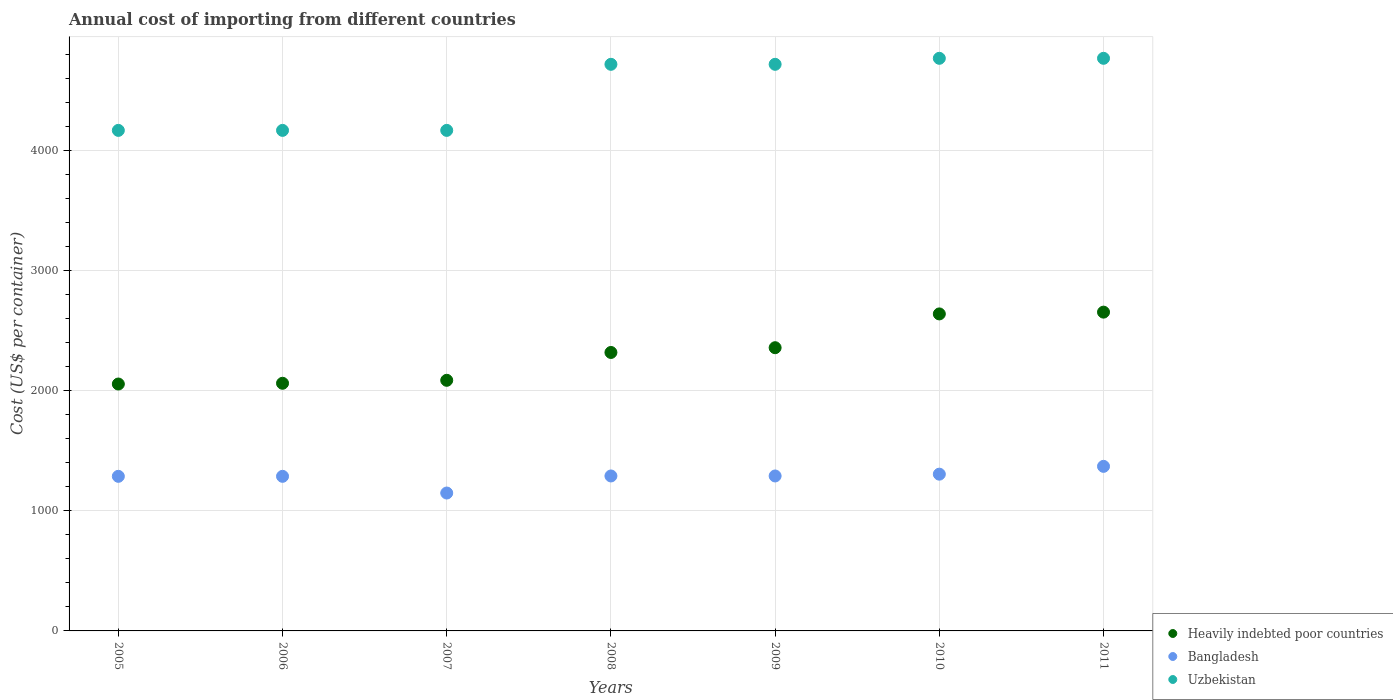How many different coloured dotlines are there?
Make the answer very short. 3. Is the number of dotlines equal to the number of legend labels?
Provide a succinct answer. Yes. What is the total annual cost of importing in Heavily indebted poor countries in 2008?
Your answer should be very brief. 2318.13. Across all years, what is the maximum total annual cost of importing in Bangladesh?
Provide a succinct answer. 1370. Across all years, what is the minimum total annual cost of importing in Heavily indebted poor countries?
Your answer should be compact. 2055.43. What is the total total annual cost of importing in Heavily indebted poor countries in the graph?
Offer a very short reply. 1.62e+04. What is the difference between the total annual cost of importing in Heavily indebted poor countries in 2009 and that in 2010?
Offer a terse response. -281.26. What is the difference between the total annual cost of importing in Heavily indebted poor countries in 2010 and the total annual cost of importing in Uzbekistan in 2009?
Provide a succinct answer. -2077.95. What is the average total annual cost of importing in Heavily indebted poor countries per year?
Make the answer very short. 2310.33. In the year 2005, what is the difference between the total annual cost of importing in Uzbekistan and total annual cost of importing in Bangladesh?
Offer a terse response. 2880. In how many years, is the total annual cost of importing in Heavily indebted poor countries greater than 3800 US$?
Your answer should be very brief. 0. What is the ratio of the total annual cost of importing in Heavily indebted poor countries in 2005 to that in 2008?
Give a very brief answer. 0.89. Is the total annual cost of importing in Heavily indebted poor countries in 2006 less than that in 2007?
Your answer should be compact. Yes. Is the difference between the total annual cost of importing in Uzbekistan in 2005 and 2008 greater than the difference between the total annual cost of importing in Bangladesh in 2005 and 2008?
Your response must be concise. No. What is the difference between the highest and the second highest total annual cost of importing in Bangladesh?
Your response must be concise. 65. What is the difference between the highest and the lowest total annual cost of importing in Bangladesh?
Make the answer very short. 222. In how many years, is the total annual cost of importing in Heavily indebted poor countries greater than the average total annual cost of importing in Heavily indebted poor countries taken over all years?
Provide a succinct answer. 4. Is it the case that in every year, the sum of the total annual cost of importing in Bangladesh and total annual cost of importing in Uzbekistan  is greater than the total annual cost of importing in Heavily indebted poor countries?
Ensure brevity in your answer.  Yes. Does the total annual cost of importing in Uzbekistan monotonically increase over the years?
Give a very brief answer. No. Is the total annual cost of importing in Heavily indebted poor countries strictly greater than the total annual cost of importing in Uzbekistan over the years?
Offer a very short reply. No. Is the total annual cost of importing in Bangladesh strictly less than the total annual cost of importing in Uzbekistan over the years?
Provide a succinct answer. Yes. What is the difference between two consecutive major ticks on the Y-axis?
Your answer should be very brief. 1000. Does the graph contain grids?
Give a very brief answer. Yes. What is the title of the graph?
Ensure brevity in your answer.  Annual cost of importing from different countries. What is the label or title of the X-axis?
Ensure brevity in your answer.  Years. What is the label or title of the Y-axis?
Provide a succinct answer. Cost (US$ per container). What is the Cost (US$ per container) of Heavily indebted poor countries in 2005?
Keep it short and to the point. 2055.43. What is the Cost (US$ per container) in Bangladesh in 2005?
Keep it short and to the point. 1287. What is the Cost (US$ per container) of Uzbekistan in 2005?
Your answer should be compact. 4167. What is the Cost (US$ per container) of Heavily indebted poor countries in 2006?
Provide a succinct answer. 2061.68. What is the Cost (US$ per container) of Bangladesh in 2006?
Offer a very short reply. 1287. What is the Cost (US$ per container) of Uzbekistan in 2006?
Keep it short and to the point. 4167. What is the Cost (US$ per container) of Heavily indebted poor countries in 2007?
Keep it short and to the point. 2086.37. What is the Cost (US$ per container) in Bangladesh in 2007?
Ensure brevity in your answer.  1148. What is the Cost (US$ per container) of Uzbekistan in 2007?
Offer a terse response. 4167. What is the Cost (US$ per container) of Heavily indebted poor countries in 2008?
Keep it short and to the point. 2318.13. What is the Cost (US$ per container) of Bangladesh in 2008?
Your response must be concise. 1290. What is the Cost (US$ per container) of Uzbekistan in 2008?
Offer a terse response. 4717. What is the Cost (US$ per container) of Heavily indebted poor countries in 2009?
Provide a succinct answer. 2357.79. What is the Cost (US$ per container) of Bangladesh in 2009?
Give a very brief answer. 1290. What is the Cost (US$ per container) in Uzbekistan in 2009?
Offer a terse response. 4717. What is the Cost (US$ per container) of Heavily indebted poor countries in 2010?
Provide a succinct answer. 2639.05. What is the Cost (US$ per container) of Bangladesh in 2010?
Give a very brief answer. 1305. What is the Cost (US$ per container) in Uzbekistan in 2010?
Provide a short and direct response. 4767. What is the Cost (US$ per container) in Heavily indebted poor countries in 2011?
Keep it short and to the point. 2653.87. What is the Cost (US$ per container) in Bangladesh in 2011?
Your answer should be compact. 1370. What is the Cost (US$ per container) of Uzbekistan in 2011?
Provide a succinct answer. 4767. Across all years, what is the maximum Cost (US$ per container) of Heavily indebted poor countries?
Offer a terse response. 2653.87. Across all years, what is the maximum Cost (US$ per container) of Bangladesh?
Your answer should be very brief. 1370. Across all years, what is the maximum Cost (US$ per container) of Uzbekistan?
Provide a succinct answer. 4767. Across all years, what is the minimum Cost (US$ per container) in Heavily indebted poor countries?
Your answer should be compact. 2055.43. Across all years, what is the minimum Cost (US$ per container) in Bangladesh?
Keep it short and to the point. 1148. Across all years, what is the minimum Cost (US$ per container) in Uzbekistan?
Ensure brevity in your answer.  4167. What is the total Cost (US$ per container) in Heavily indebted poor countries in the graph?
Keep it short and to the point. 1.62e+04. What is the total Cost (US$ per container) of Bangladesh in the graph?
Offer a very short reply. 8977. What is the total Cost (US$ per container) in Uzbekistan in the graph?
Your answer should be very brief. 3.15e+04. What is the difference between the Cost (US$ per container) in Heavily indebted poor countries in 2005 and that in 2006?
Your answer should be compact. -6.25. What is the difference between the Cost (US$ per container) of Bangladesh in 2005 and that in 2006?
Offer a very short reply. 0. What is the difference between the Cost (US$ per container) in Heavily indebted poor countries in 2005 and that in 2007?
Give a very brief answer. -30.94. What is the difference between the Cost (US$ per container) of Bangladesh in 2005 and that in 2007?
Your response must be concise. 139. What is the difference between the Cost (US$ per container) of Heavily indebted poor countries in 2005 and that in 2008?
Your response must be concise. -262.7. What is the difference between the Cost (US$ per container) in Uzbekistan in 2005 and that in 2008?
Give a very brief answer. -550. What is the difference between the Cost (US$ per container) in Heavily indebted poor countries in 2005 and that in 2009?
Offer a very short reply. -302.36. What is the difference between the Cost (US$ per container) in Bangladesh in 2005 and that in 2009?
Your answer should be compact. -3. What is the difference between the Cost (US$ per container) in Uzbekistan in 2005 and that in 2009?
Offer a very short reply. -550. What is the difference between the Cost (US$ per container) of Heavily indebted poor countries in 2005 and that in 2010?
Your answer should be very brief. -583.62. What is the difference between the Cost (US$ per container) of Bangladesh in 2005 and that in 2010?
Make the answer very short. -18. What is the difference between the Cost (US$ per container) of Uzbekistan in 2005 and that in 2010?
Give a very brief answer. -600. What is the difference between the Cost (US$ per container) of Heavily indebted poor countries in 2005 and that in 2011?
Your response must be concise. -598.44. What is the difference between the Cost (US$ per container) of Bangladesh in 2005 and that in 2011?
Offer a very short reply. -83. What is the difference between the Cost (US$ per container) in Uzbekistan in 2005 and that in 2011?
Offer a very short reply. -600. What is the difference between the Cost (US$ per container) in Heavily indebted poor countries in 2006 and that in 2007?
Give a very brief answer. -24.68. What is the difference between the Cost (US$ per container) of Bangladesh in 2006 and that in 2007?
Give a very brief answer. 139. What is the difference between the Cost (US$ per container) in Heavily indebted poor countries in 2006 and that in 2008?
Your answer should be compact. -256.45. What is the difference between the Cost (US$ per container) in Bangladesh in 2006 and that in 2008?
Offer a very short reply. -3. What is the difference between the Cost (US$ per container) in Uzbekistan in 2006 and that in 2008?
Offer a terse response. -550. What is the difference between the Cost (US$ per container) of Heavily indebted poor countries in 2006 and that in 2009?
Offer a very short reply. -296.11. What is the difference between the Cost (US$ per container) in Uzbekistan in 2006 and that in 2009?
Make the answer very short. -550. What is the difference between the Cost (US$ per container) of Heavily indebted poor countries in 2006 and that in 2010?
Offer a terse response. -577.37. What is the difference between the Cost (US$ per container) of Bangladesh in 2006 and that in 2010?
Give a very brief answer. -18. What is the difference between the Cost (US$ per container) of Uzbekistan in 2006 and that in 2010?
Your response must be concise. -600. What is the difference between the Cost (US$ per container) in Heavily indebted poor countries in 2006 and that in 2011?
Keep it short and to the point. -592.18. What is the difference between the Cost (US$ per container) in Bangladesh in 2006 and that in 2011?
Your answer should be very brief. -83. What is the difference between the Cost (US$ per container) in Uzbekistan in 2006 and that in 2011?
Provide a succinct answer. -600. What is the difference between the Cost (US$ per container) in Heavily indebted poor countries in 2007 and that in 2008?
Ensure brevity in your answer.  -231.76. What is the difference between the Cost (US$ per container) in Bangladesh in 2007 and that in 2008?
Make the answer very short. -142. What is the difference between the Cost (US$ per container) in Uzbekistan in 2007 and that in 2008?
Ensure brevity in your answer.  -550. What is the difference between the Cost (US$ per container) of Heavily indebted poor countries in 2007 and that in 2009?
Your answer should be compact. -271.42. What is the difference between the Cost (US$ per container) in Bangladesh in 2007 and that in 2009?
Offer a terse response. -142. What is the difference between the Cost (US$ per container) of Uzbekistan in 2007 and that in 2009?
Your response must be concise. -550. What is the difference between the Cost (US$ per container) of Heavily indebted poor countries in 2007 and that in 2010?
Your answer should be compact. -552.68. What is the difference between the Cost (US$ per container) in Bangladesh in 2007 and that in 2010?
Give a very brief answer. -157. What is the difference between the Cost (US$ per container) of Uzbekistan in 2007 and that in 2010?
Your answer should be compact. -600. What is the difference between the Cost (US$ per container) in Heavily indebted poor countries in 2007 and that in 2011?
Provide a short and direct response. -567.5. What is the difference between the Cost (US$ per container) of Bangladesh in 2007 and that in 2011?
Ensure brevity in your answer.  -222. What is the difference between the Cost (US$ per container) in Uzbekistan in 2007 and that in 2011?
Your answer should be very brief. -600. What is the difference between the Cost (US$ per container) of Heavily indebted poor countries in 2008 and that in 2009?
Give a very brief answer. -39.66. What is the difference between the Cost (US$ per container) of Heavily indebted poor countries in 2008 and that in 2010?
Provide a succinct answer. -320.92. What is the difference between the Cost (US$ per container) in Uzbekistan in 2008 and that in 2010?
Make the answer very short. -50. What is the difference between the Cost (US$ per container) in Heavily indebted poor countries in 2008 and that in 2011?
Keep it short and to the point. -335.74. What is the difference between the Cost (US$ per container) of Bangladesh in 2008 and that in 2011?
Your response must be concise. -80. What is the difference between the Cost (US$ per container) in Heavily indebted poor countries in 2009 and that in 2010?
Provide a short and direct response. -281.26. What is the difference between the Cost (US$ per container) of Bangladesh in 2009 and that in 2010?
Ensure brevity in your answer.  -15. What is the difference between the Cost (US$ per container) of Heavily indebted poor countries in 2009 and that in 2011?
Your answer should be very brief. -296.08. What is the difference between the Cost (US$ per container) in Bangladesh in 2009 and that in 2011?
Provide a succinct answer. -80. What is the difference between the Cost (US$ per container) in Heavily indebted poor countries in 2010 and that in 2011?
Provide a short and direct response. -14.82. What is the difference between the Cost (US$ per container) of Bangladesh in 2010 and that in 2011?
Offer a terse response. -65. What is the difference between the Cost (US$ per container) of Uzbekistan in 2010 and that in 2011?
Provide a succinct answer. 0. What is the difference between the Cost (US$ per container) of Heavily indebted poor countries in 2005 and the Cost (US$ per container) of Bangladesh in 2006?
Ensure brevity in your answer.  768.43. What is the difference between the Cost (US$ per container) of Heavily indebted poor countries in 2005 and the Cost (US$ per container) of Uzbekistan in 2006?
Your answer should be compact. -2111.57. What is the difference between the Cost (US$ per container) of Bangladesh in 2005 and the Cost (US$ per container) of Uzbekistan in 2006?
Give a very brief answer. -2880. What is the difference between the Cost (US$ per container) in Heavily indebted poor countries in 2005 and the Cost (US$ per container) in Bangladesh in 2007?
Ensure brevity in your answer.  907.43. What is the difference between the Cost (US$ per container) in Heavily indebted poor countries in 2005 and the Cost (US$ per container) in Uzbekistan in 2007?
Your response must be concise. -2111.57. What is the difference between the Cost (US$ per container) of Bangladesh in 2005 and the Cost (US$ per container) of Uzbekistan in 2007?
Keep it short and to the point. -2880. What is the difference between the Cost (US$ per container) of Heavily indebted poor countries in 2005 and the Cost (US$ per container) of Bangladesh in 2008?
Ensure brevity in your answer.  765.43. What is the difference between the Cost (US$ per container) in Heavily indebted poor countries in 2005 and the Cost (US$ per container) in Uzbekistan in 2008?
Give a very brief answer. -2661.57. What is the difference between the Cost (US$ per container) in Bangladesh in 2005 and the Cost (US$ per container) in Uzbekistan in 2008?
Make the answer very short. -3430. What is the difference between the Cost (US$ per container) of Heavily indebted poor countries in 2005 and the Cost (US$ per container) of Bangladesh in 2009?
Your response must be concise. 765.43. What is the difference between the Cost (US$ per container) of Heavily indebted poor countries in 2005 and the Cost (US$ per container) of Uzbekistan in 2009?
Provide a short and direct response. -2661.57. What is the difference between the Cost (US$ per container) of Bangladesh in 2005 and the Cost (US$ per container) of Uzbekistan in 2009?
Ensure brevity in your answer.  -3430. What is the difference between the Cost (US$ per container) in Heavily indebted poor countries in 2005 and the Cost (US$ per container) in Bangladesh in 2010?
Ensure brevity in your answer.  750.43. What is the difference between the Cost (US$ per container) of Heavily indebted poor countries in 2005 and the Cost (US$ per container) of Uzbekistan in 2010?
Your answer should be very brief. -2711.57. What is the difference between the Cost (US$ per container) of Bangladesh in 2005 and the Cost (US$ per container) of Uzbekistan in 2010?
Offer a terse response. -3480. What is the difference between the Cost (US$ per container) of Heavily indebted poor countries in 2005 and the Cost (US$ per container) of Bangladesh in 2011?
Keep it short and to the point. 685.43. What is the difference between the Cost (US$ per container) in Heavily indebted poor countries in 2005 and the Cost (US$ per container) in Uzbekistan in 2011?
Offer a terse response. -2711.57. What is the difference between the Cost (US$ per container) of Bangladesh in 2005 and the Cost (US$ per container) of Uzbekistan in 2011?
Keep it short and to the point. -3480. What is the difference between the Cost (US$ per container) of Heavily indebted poor countries in 2006 and the Cost (US$ per container) of Bangladesh in 2007?
Keep it short and to the point. 913.68. What is the difference between the Cost (US$ per container) in Heavily indebted poor countries in 2006 and the Cost (US$ per container) in Uzbekistan in 2007?
Offer a terse response. -2105.32. What is the difference between the Cost (US$ per container) in Bangladesh in 2006 and the Cost (US$ per container) in Uzbekistan in 2007?
Provide a succinct answer. -2880. What is the difference between the Cost (US$ per container) in Heavily indebted poor countries in 2006 and the Cost (US$ per container) in Bangladesh in 2008?
Keep it short and to the point. 771.68. What is the difference between the Cost (US$ per container) of Heavily indebted poor countries in 2006 and the Cost (US$ per container) of Uzbekistan in 2008?
Provide a short and direct response. -2655.32. What is the difference between the Cost (US$ per container) of Bangladesh in 2006 and the Cost (US$ per container) of Uzbekistan in 2008?
Offer a terse response. -3430. What is the difference between the Cost (US$ per container) in Heavily indebted poor countries in 2006 and the Cost (US$ per container) in Bangladesh in 2009?
Offer a terse response. 771.68. What is the difference between the Cost (US$ per container) in Heavily indebted poor countries in 2006 and the Cost (US$ per container) in Uzbekistan in 2009?
Your answer should be very brief. -2655.32. What is the difference between the Cost (US$ per container) of Bangladesh in 2006 and the Cost (US$ per container) of Uzbekistan in 2009?
Offer a very short reply. -3430. What is the difference between the Cost (US$ per container) of Heavily indebted poor countries in 2006 and the Cost (US$ per container) of Bangladesh in 2010?
Keep it short and to the point. 756.68. What is the difference between the Cost (US$ per container) of Heavily indebted poor countries in 2006 and the Cost (US$ per container) of Uzbekistan in 2010?
Offer a very short reply. -2705.32. What is the difference between the Cost (US$ per container) of Bangladesh in 2006 and the Cost (US$ per container) of Uzbekistan in 2010?
Offer a terse response. -3480. What is the difference between the Cost (US$ per container) of Heavily indebted poor countries in 2006 and the Cost (US$ per container) of Bangladesh in 2011?
Offer a terse response. 691.68. What is the difference between the Cost (US$ per container) of Heavily indebted poor countries in 2006 and the Cost (US$ per container) of Uzbekistan in 2011?
Make the answer very short. -2705.32. What is the difference between the Cost (US$ per container) of Bangladesh in 2006 and the Cost (US$ per container) of Uzbekistan in 2011?
Your answer should be compact. -3480. What is the difference between the Cost (US$ per container) in Heavily indebted poor countries in 2007 and the Cost (US$ per container) in Bangladesh in 2008?
Give a very brief answer. 796.37. What is the difference between the Cost (US$ per container) in Heavily indebted poor countries in 2007 and the Cost (US$ per container) in Uzbekistan in 2008?
Offer a terse response. -2630.63. What is the difference between the Cost (US$ per container) of Bangladesh in 2007 and the Cost (US$ per container) of Uzbekistan in 2008?
Offer a terse response. -3569. What is the difference between the Cost (US$ per container) in Heavily indebted poor countries in 2007 and the Cost (US$ per container) in Bangladesh in 2009?
Offer a very short reply. 796.37. What is the difference between the Cost (US$ per container) in Heavily indebted poor countries in 2007 and the Cost (US$ per container) in Uzbekistan in 2009?
Keep it short and to the point. -2630.63. What is the difference between the Cost (US$ per container) of Bangladesh in 2007 and the Cost (US$ per container) of Uzbekistan in 2009?
Offer a terse response. -3569. What is the difference between the Cost (US$ per container) of Heavily indebted poor countries in 2007 and the Cost (US$ per container) of Bangladesh in 2010?
Offer a terse response. 781.37. What is the difference between the Cost (US$ per container) in Heavily indebted poor countries in 2007 and the Cost (US$ per container) in Uzbekistan in 2010?
Offer a terse response. -2680.63. What is the difference between the Cost (US$ per container) in Bangladesh in 2007 and the Cost (US$ per container) in Uzbekistan in 2010?
Provide a succinct answer. -3619. What is the difference between the Cost (US$ per container) of Heavily indebted poor countries in 2007 and the Cost (US$ per container) of Bangladesh in 2011?
Ensure brevity in your answer.  716.37. What is the difference between the Cost (US$ per container) in Heavily indebted poor countries in 2007 and the Cost (US$ per container) in Uzbekistan in 2011?
Make the answer very short. -2680.63. What is the difference between the Cost (US$ per container) in Bangladesh in 2007 and the Cost (US$ per container) in Uzbekistan in 2011?
Your answer should be compact. -3619. What is the difference between the Cost (US$ per container) in Heavily indebted poor countries in 2008 and the Cost (US$ per container) in Bangladesh in 2009?
Give a very brief answer. 1028.13. What is the difference between the Cost (US$ per container) of Heavily indebted poor countries in 2008 and the Cost (US$ per container) of Uzbekistan in 2009?
Your answer should be compact. -2398.87. What is the difference between the Cost (US$ per container) in Bangladesh in 2008 and the Cost (US$ per container) in Uzbekistan in 2009?
Your response must be concise. -3427. What is the difference between the Cost (US$ per container) of Heavily indebted poor countries in 2008 and the Cost (US$ per container) of Bangladesh in 2010?
Your response must be concise. 1013.13. What is the difference between the Cost (US$ per container) of Heavily indebted poor countries in 2008 and the Cost (US$ per container) of Uzbekistan in 2010?
Make the answer very short. -2448.87. What is the difference between the Cost (US$ per container) in Bangladesh in 2008 and the Cost (US$ per container) in Uzbekistan in 2010?
Your response must be concise. -3477. What is the difference between the Cost (US$ per container) in Heavily indebted poor countries in 2008 and the Cost (US$ per container) in Bangladesh in 2011?
Give a very brief answer. 948.13. What is the difference between the Cost (US$ per container) of Heavily indebted poor countries in 2008 and the Cost (US$ per container) of Uzbekistan in 2011?
Ensure brevity in your answer.  -2448.87. What is the difference between the Cost (US$ per container) of Bangladesh in 2008 and the Cost (US$ per container) of Uzbekistan in 2011?
Your answer should be very brief. -3477. What is the difference between the Cost (US$ per container) in Heavily indebted poor countries in 2009 and the Cost (US$ per container) in Bangladesh in 2010?
Give a very brief answer. 1052.79. What is the difference between the Cost (US$ per container) in Heavily indebted poor countries in 2009 and the Cost (US$ per container) in Uzbekistan in 2010?
Give a very brief answer. -2409.21. What is the difference between the Cost (US$ per container) of Bangladesh in 2009 and the Cost (US$ per container) of Uzbekistan in 2010?
Your answer should be compact. -3477. What is the difference between the Cost (US$ per container) of Heavily indebted poor countries in 2009 and the Cost (US$ per container) of Bangladesh in 2011?
Your answer should be compact. 987.79. What is the difference between the Cost (US$ per container) of Heavily indebted poor countries in 2009 and the Cost (US$ per container) of Uzbekistan in 2011?
Give a very brief answer. -2409.21. What is the difference between the Cost (US$ per container) of Bangladesh in 2009 and the Cost (US$ per container) of Uzbekistan in 2011?
Give a very brief answer. -3477. What is the difference between the Cost (US$ per container) of Heavily indebted poor countries in 2010 and the Cost (US$ per container) of Bangladesh in 2011?
Make the answer very short. 1269.05. What is the difference between the Cost (US$ per container) of Heavily indebted poor countries in 2010 and the Cost (US$ per container) of Uzbekistan in 2011?
Give a very brief answer. -2127.95. What is the difference between the Cost (US$ per container) of Bangladesh in 2010 and the Cost (US$ per container) of Uzbekistan in 2011?
Offer a terse response. -3462. What is the average Cost (US$ per container) of Heavily indebted poor countries per year?
Provide a short and direct response. 2310.33. What is the average Cost (US$ per container) in Bangladesh per year?
Your answer should be very brief. 1282.43. What is the average Cost (US$ per container) in Uzbekistan per year?
Make the answer very short. 4495.57. In the year 2005, what is the difference between the Cost (US$ per container) in Heavily indebted poor countries and Cost (US$ per container) in Bangladesh?
Your response must be concise. 768.43. In the year 2005, what is the difference between the Cost (US$ per container) of Heavily indebted poor countries and Cost (US$ per container) of Uzbekistan?
Keep it short and to the point. -2111.57. In the year 2005, what is the difference between the Cost (US$ per container) in Bangladesh and Cost (US$ per container) in Uzbekistan?
Make the answer very short. -2880. In the year 2006, what is the difference between the Cost (US$ per container) in Heavily indebted poor countries and Cost (US$ per container) in Bangladesh?
Your answer should be compact. 774.68. In the year 2006, what is the difference between the Cost (US$ per container) in Heavily indebted poor countries and Cost (US$ per container) in Uzbekistan?
Make the answer very short. -2105.32. In the year 2006, what is the difference between the Cost (US$ per container) in Bangladesh and Cost (US$ per container) in Uzbekistan?
Your response must be concise. -2880. In the year 2007, what is the difference between the Cost (US$ per container) of Heavily indebted poor countries and Cost (US$ per container) of Bangladesh?
Keep it short and to the point. 938.37. In the year 2007, what is the difference between the Cost (US$ per container) in Heavily indebted poor countries and Cost (US$ per container) in Uzbekistan?
Ensure brevity in your answer.  -2080.63. In the year 2007, what is the difference between the Cost (US$ per container) of Bangladesh and Cost (US$ per container) of Uzbekistan?
Keep it short and to the point. -3019. In the year 2008, what is the difference between the Cost (US$ per container) in Heavily indebted poor countries and Cost (US$ per container) in Bangladesh?
Provide a short and direct response. 1028.13. In the year 2008, what is the difference between the Cost (US$ per container) of Heavily indebted poor countries and Cost (US$ per container) of Uzbekistan?
Keep it short and to the point. -2398.87. In the year 2008, what is the difference between the Cost (US$ per container) in Bangladesh and Cost (US$ per container) in Uzbekistan?
Provide a short and direct response. -3427. In the year 2009, what is the difference between the Cost (US$ per container) in Heavily indebted poor countries and Cost (US$ per container) in Bangladesh?
Keep it short and to the point. 1067.79. In the year 2009, what is the difference between the Cost (US$ per container) of Heavily indebted poor countries and Cost (US$ per container) of Uzbekistan?
Provide a succinct answer. -2359.21. In the year 2009, what is the difference between the Cost (US$ per container) in Bangladesh and Cost (US$ per container) in Uzbekistan?
Your answer should be very brief. -3427. In the year 2010, what is the difference between the Cost (US$ per container) of Heavily indebted poor countries and Cost (US$ per container) of Bangladesh?
Your answer should be very brief. 1334.05. In the year 2010, what is the difference between the Cost (US$ per container) in Heavily indebted poor countries and Cost (US$ per container) in Uzbekistan?
Give a very brief answer. -2127.95. In the year 2010, what is the difference between the Cost (US$ per container) in Bangladesh and Cost (US$ per container) in Uzbekistan?
Your response must be concise. -3462. In the year 2011, what is the difference between the Cost (US$ per container) in Heavily indebted poor countries and Cost (US$ per container) in Bangladesh?
Make the answer very short. 1283.87. In the year 2011, what is the difference between the Cost (US$ per container) in Heavily indebted poor countries and Cost (US$ per container) in Uzbekistan?
Your response must be concise. -2113.13. In the year 2011, what is the difference between the Cost (US$ per container) in Bangladesh and Cost (US$ per container) in Uzbekistan?
Offer a very short reply. -3397. What is the ratio of the Cost (US$ per container) in Heavily indebted poor countries in 2005 to that in 2006?
Your response must be concise. 1. What is the ratio of the Cost (US$ per container) of Bangladesh in 2005 to that in 2006?
Your answer should be very brief. 1. What is the ratio of the Cost (US$ per container) of Heavily indebted poor countries in 2005 to that in 2007?
Provide a short and direct response. 0.99. What is the ratio of the Cost (US$ per container) of Bangladesh in 2005 to that in 2007?
Ensure brevity in your answer.  1.12. What is the ratio of the Cost (US$ per container) in Heavily indebted poor countries in 2005 to that in 2008?
Offer a very short reply. 0.89. What is the ratio of the Cost (US$ per container) in Uzbekistan in 2005 to that in 2008?
Give a very brief answer. 0.88. What is the ratio of the Cost (US$ per container) in Heavily indebted poor countries in 2005 to that in 2009?
Your answer should be compact. 0.87. What is the ratio of the Cost (US$ per container) of Bangladesh in 2005 to that in 2009?
Provide a short and direct response. 1. What is the ratio of the Cost (US$ per container) of Uzbekistan in 2005 to that in 2009?
Offer a very short reply. 0.88. What is the ratio of the Cost (US$ per container) in Heavily indebted poor countries in 2005 to that in 2010?
Provide a short and direct response. 0.78. What is the ratio of the Cost (US$ per container) in Bangladesh in 2005 to that in 2010?
Make the answer very short. 0.99. What is the ratio of the Cost (US$ per container) in Uzbekistan in 2005 to that in 2010?
Your answer should be compact. 0.87. What is the ratio of the Cost (US$ per container) of Heavily indebted poor countries in 2005 to that in 2011?
Ensure brevity in your answer.  0.77. What is the ratio of the Cost (US$ per container) in Bangladesh in 2005 to that in 2011?
Keep it short and to the point. 0.94. What is the ratio of the Cost (US$ per container) in Uzbekistan in 2005 to that in 2011?
Keep it short and to the point. 0.87. What is the ratio of the Cost (US$ per container) of Bangladesh in 2006 to that in 2007?
Give a very brief answer. 1.12. What is the ratio of the Cost (US$ per container) of Uzbekistan in 2006 to that in 2007?
Keep it short and to the point. 1. What is the ratio of the Cost (US$ per container) in Heavily indebted poor countries in 2006 to that in 2008?
Keep it short and to the point. 0.89. What is the ratio of the Cost (US$ per container) in Uzbekistan in 2006 to that in 2008?
Your answer should be compact. 0.88. What is the ratio of the Cost (US$ per container) in Heavily indebted poor countries in 2006 to that in 2009?
Give a very brief answer. 0.87. What is the ratio of the Cost (US$ per container) in Bangladesh in 2006 to that in 2009?
Keep it short and to the point. 1. What is the ratio of the Cost (US$ per container) of Uzbekistan in 2006 to that in 2009?
Make the answer very short. 0.88. What is the ratio of the Cost (US$ per container) of Heavily indebted poor countries in 2006 to that in 2010?
Offer a terse response. 0.78. What is the ratio of the Cost (US$ per container) in Bangladesh in 2006 to that in 2010?
Make the answer very short. 0.99. What is the ratio of the Cost (US$ per container) in Uzbekistan in 2006 to that in 2010?
Offer a terse response. 0.87. What is the ratio of the Cost (US$ per container) of Heavily indebted poor countries in 2006 to that in 2011?
Your answer should be very brief. 0.78. What is the ratio of the Cost (US$ per container) in Bangladesh in 2006 to that in 2011?
Your answer should be very brief. 0.94. What is the ratio of the Cost (US$ per container) in Uzbekistan in 2006 to that in 2011?
Your answer should be very brief. 0.87. What is the ratio of the Cost (US$ per container) in Bangladesh in 2007 to that in 2008?
Provide a succinct answer. 0.89. What is the ratio of the Cost (US$ per container) of Uzbekistan in 2007 to that in 2008?
Your answer should be very brief. 0.88. What is the ratio of the Cost (US$ per container) of Heavily indebted poor countries in 2007 to that in 2009?
Keep it short and to the point. 0.88. What is the ratio of the Cost (US$ per container) of Bangladesh in 2007 to that in 2009?
Give a very brief answer. 0.89. What is the ratio of the Cost (US$ per container) in Uzbekistan in 2007 to that in 2009?
Ensure brevity in your answer.  0.88. What is the ratio of the Cost (US$ per container) in Heavily indebted poor countries in 2007 to that in 2010?
Offer a terse response. 0.79. What is the ratio of the Cost (US$ per container) in Bangladesh in 2007 to that in 2010?
Your answer should be very brief. 0.88. What is the ratio of the Cost (US$ per container) of Uzbekistan in 2007 to that in 2010?
Offer a terse response. 0.87. What is the ratio of the Cost (US$ per container) in Heavily indebted poor countries in 2007 to that in 2011?
Your answer should be very brief. 0.79. What is the ratio of the Cost (US$ per container) of Bangladesh in 2007 to that in 2011?
Keep it short and to the point. 0.84. What is the ratio of the Cost (US$ per container) of Uzbekistan in 2007 to that in 2011?
Make the answer very short. 0.87. What is the ratio of the Cost (US$ per container) in Heavily indebted poor countries in 2008 to that in 2009?
Provide a short and direct response. 0.98. What is the ratio of the Cost (US$ per container) in Bangladesh in 2008 to that in 2009?
Ensure brevity in your answer.  1. What is the ratio of the Cost (US$ per container) in Uzbekistan in 2008 to that in 2009?
Your answer should be very brief. 1. What is the ratio of the Cost (US$ per container) in Heavily indebted poor countries in 2008 to that in 2010?
Give a very brief answer. 0.88. What is the ratio of the Cost (US$ per container) in Uzbekistan in 2008 to that in 2010?
Provide a short and direct response. 0.99. What is the ratio of the Cost (US$ per container) of Heavily indebted poor countries in 2008 to that in 2011?
Your answer should be compact. 0.87. What is the ratio of the Cost (US$ per container) in Bangladesh in 2008 to that in 2011?
Your response must be concise. 0.94. What is the ratio of the Cost (US$ per container) in Heavily indebted poor countries in 2009 to that in 2010?
Your answer should be very brief. 0.89. What is the ratio of the Cost (US$ per container) in Uzbekistan in 2009 to that in 2010?
Offer a very short reply. 0.99. What is the ratio of the Cost (US$ per container) in Heavily indebted poor countries in 2009 to that in 2011?
Offer a very short reply. 0.89. What is the ratio of the Cost (US$ per container) of Bangladesh in 2009 to that in 2011?
Keep it short and to the point. 0.94. What is the ratio of the Cost (US$ per container) of Uzbekistan in 2009 to that in 2011?
Provide a short and direct response. 0.99. What is the ratio of the Cost (US$ per container) of Heavily indebted poor countries in 2010 to that in 2011?
Provide a succinct answer. 0.99. What is the ratio of the Cost (US$ per container) in Bangladesh in 2010 to that in 2011?
Offer a terse response. 0.95. What is the difference between the highest and the second highest Cost (US$ per container) in Heavily indebted poor countries?
Provide a succinct answer. 14.82. What is the difference between the highest and the second highest Cost (US$ per container) of Bangladesh?
Make the answer very short. 65. What is the difference between the highest and the second highest Cost (US$ per container) of Uzbekistan?
Offer a terse response. 0. What is the difference between the highest and the lowest Cost (US$ per container) in Heavily indebted poor countries?
Your response must be concise. 598.44. What is the difference between the highest and the lowest Cost (US$ per container) of Bangladesh?
Your answer should be very brief. 222. What is the difference between the highest and the lowest Cost (US$ per container) of Uzbekistan?
Offer a terse response. 600. 